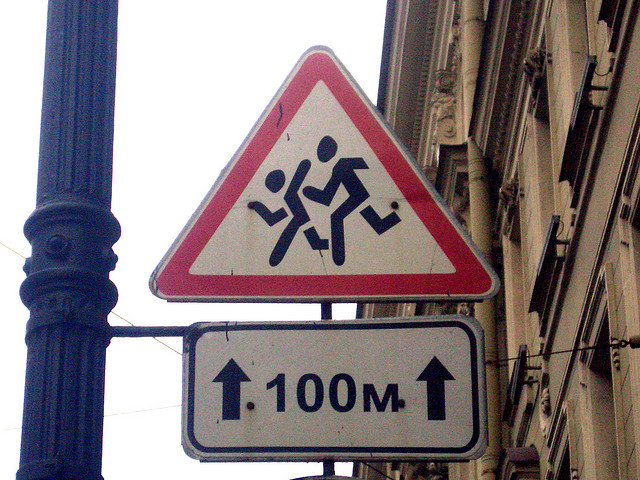<image>What business is on the building? It is ambiguous what business is on the building. It could be a store, bank, gym or library. Is the destination 100m away? It is ambiguous whether the destination is 100m away. Is the destination 100m away? I don't know if the destination is 100m away. It can be both 100m away or not. What business is on the building? I don't know what business is on the building. It can be a store, banking, gym, or a library. 